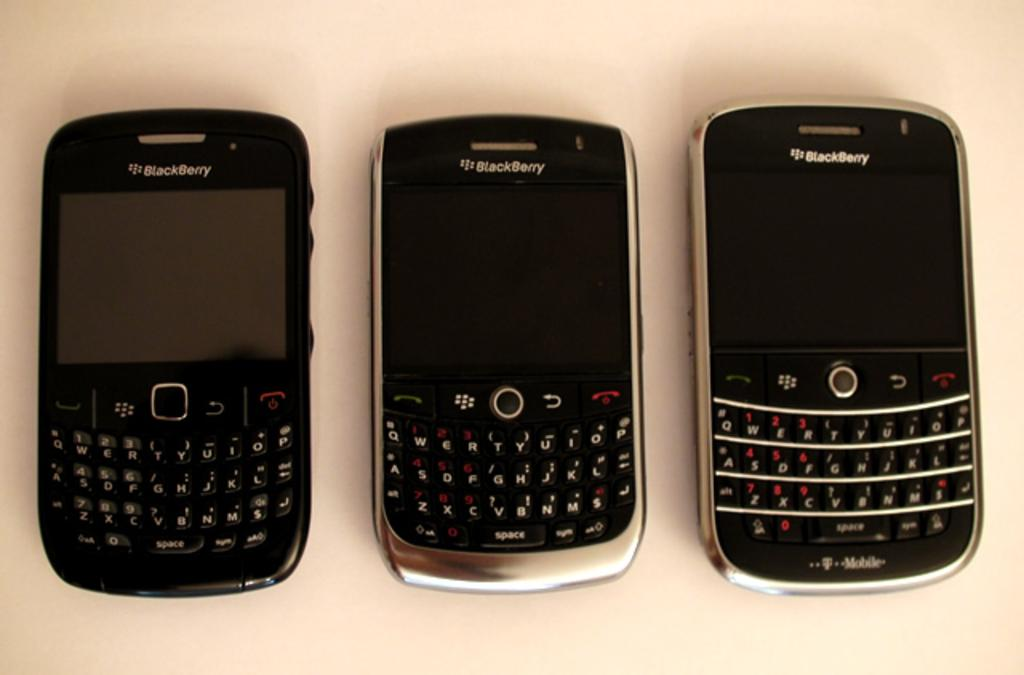Provide a one-sentence caption for the provided image. Three cell phones are on a white surface and they all say Blackberry on top. 